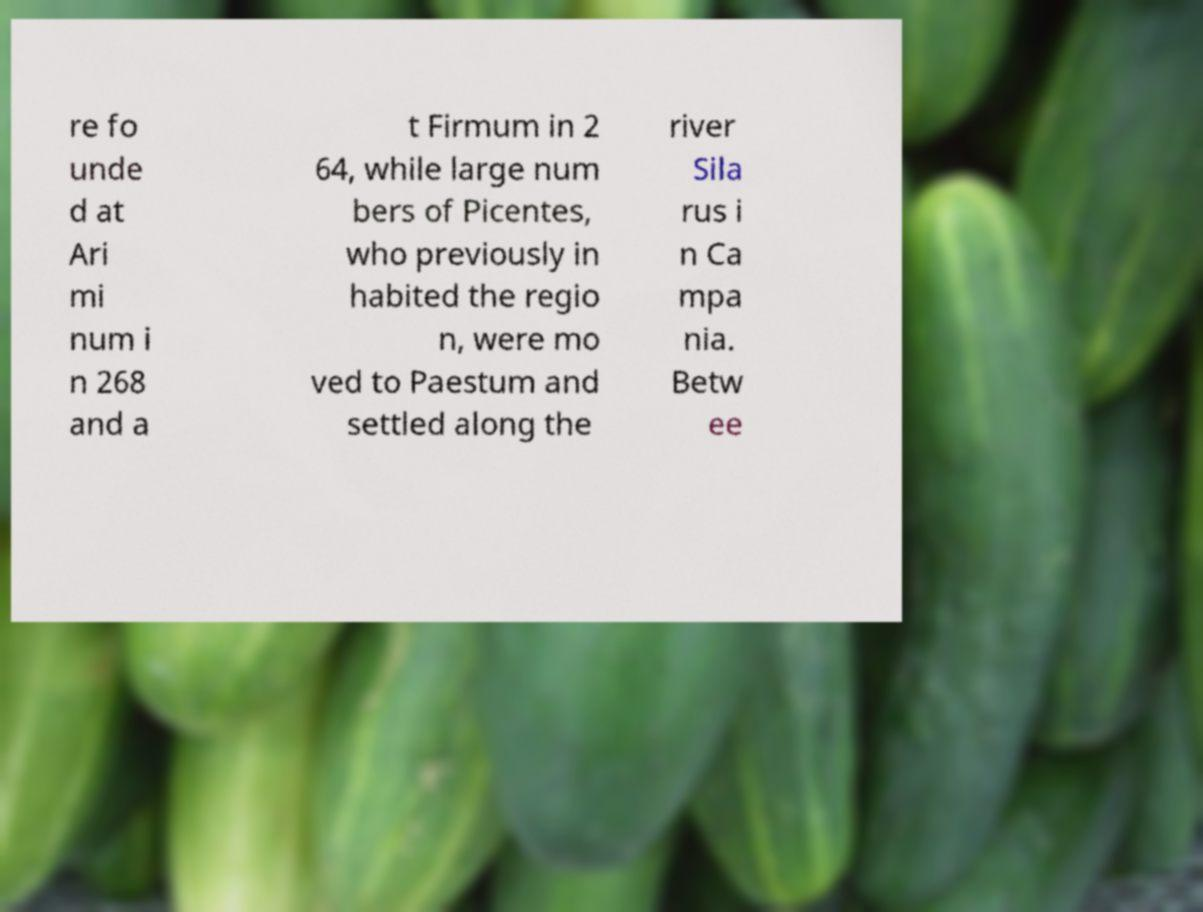What messages or text are displayed in this image? I need them in a readable, typed format. re fo unde d at Ari mi num i n 268 and a t Firmum in 2 64, while large num bers of Picentes, who previously in habited the regio n, were mo ved to Paestum and settled along the river Sila rus i n Ca mpa nia. Betw ee 